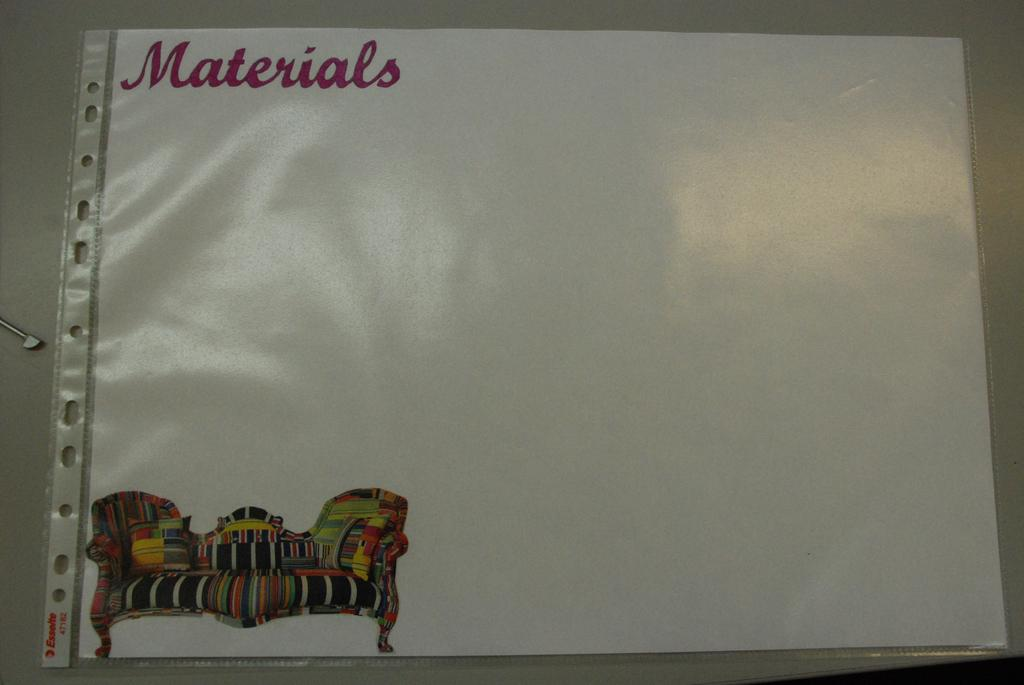<image>
Give a short and clear explanation of the subsequent image. Piece of paper in a casing with the word "materials" on it. 